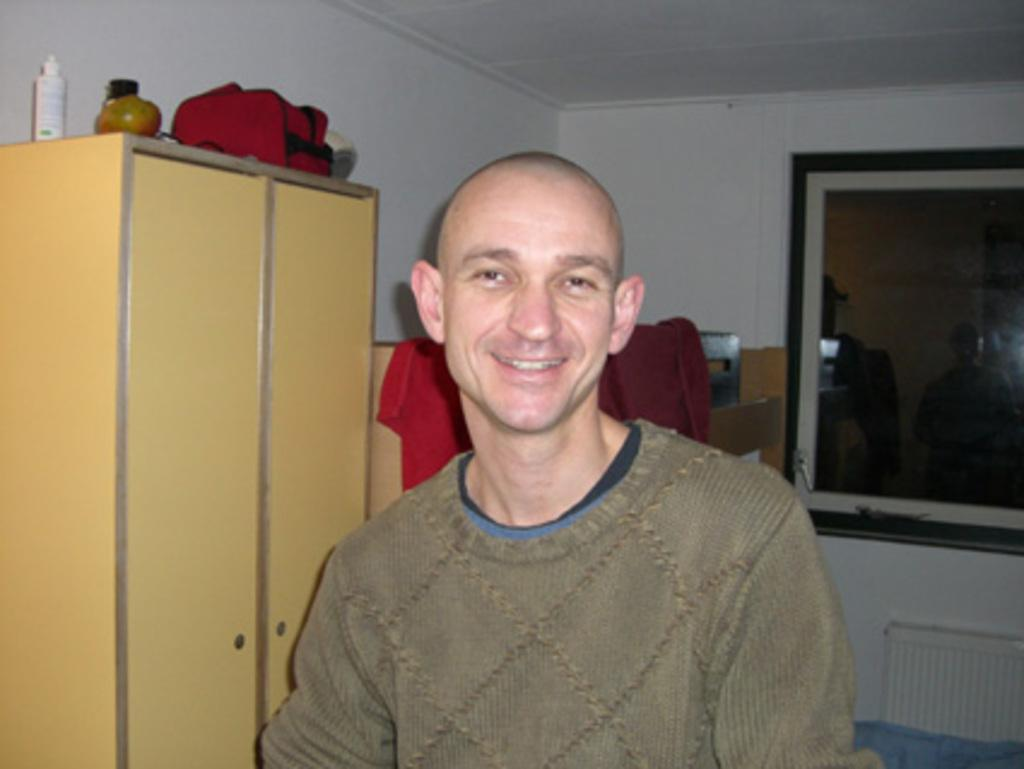Who is present in the image? There is a man in the image. What is the man doing in the image? The man is standing in the image. What is the man wearing in the image? The man is wearing a sweater in the image. What can be seen in the background of the image? There is a cupboard in the background of the image. What is visible in the image that allows natural light to enter the room? There is a window in the image. What decision does the man make in the image? There is no indication in the image that the man is making a decision. How many people are present in the image, and who are they? There is only one person present in the image, and that person is a man. 